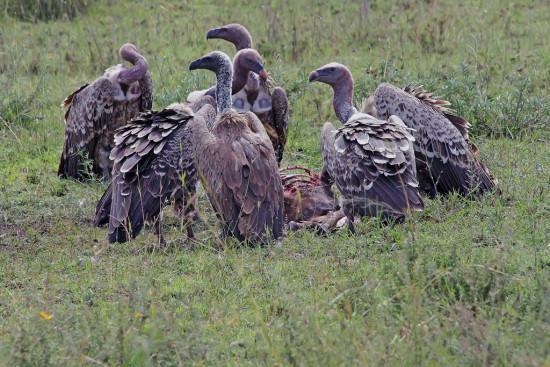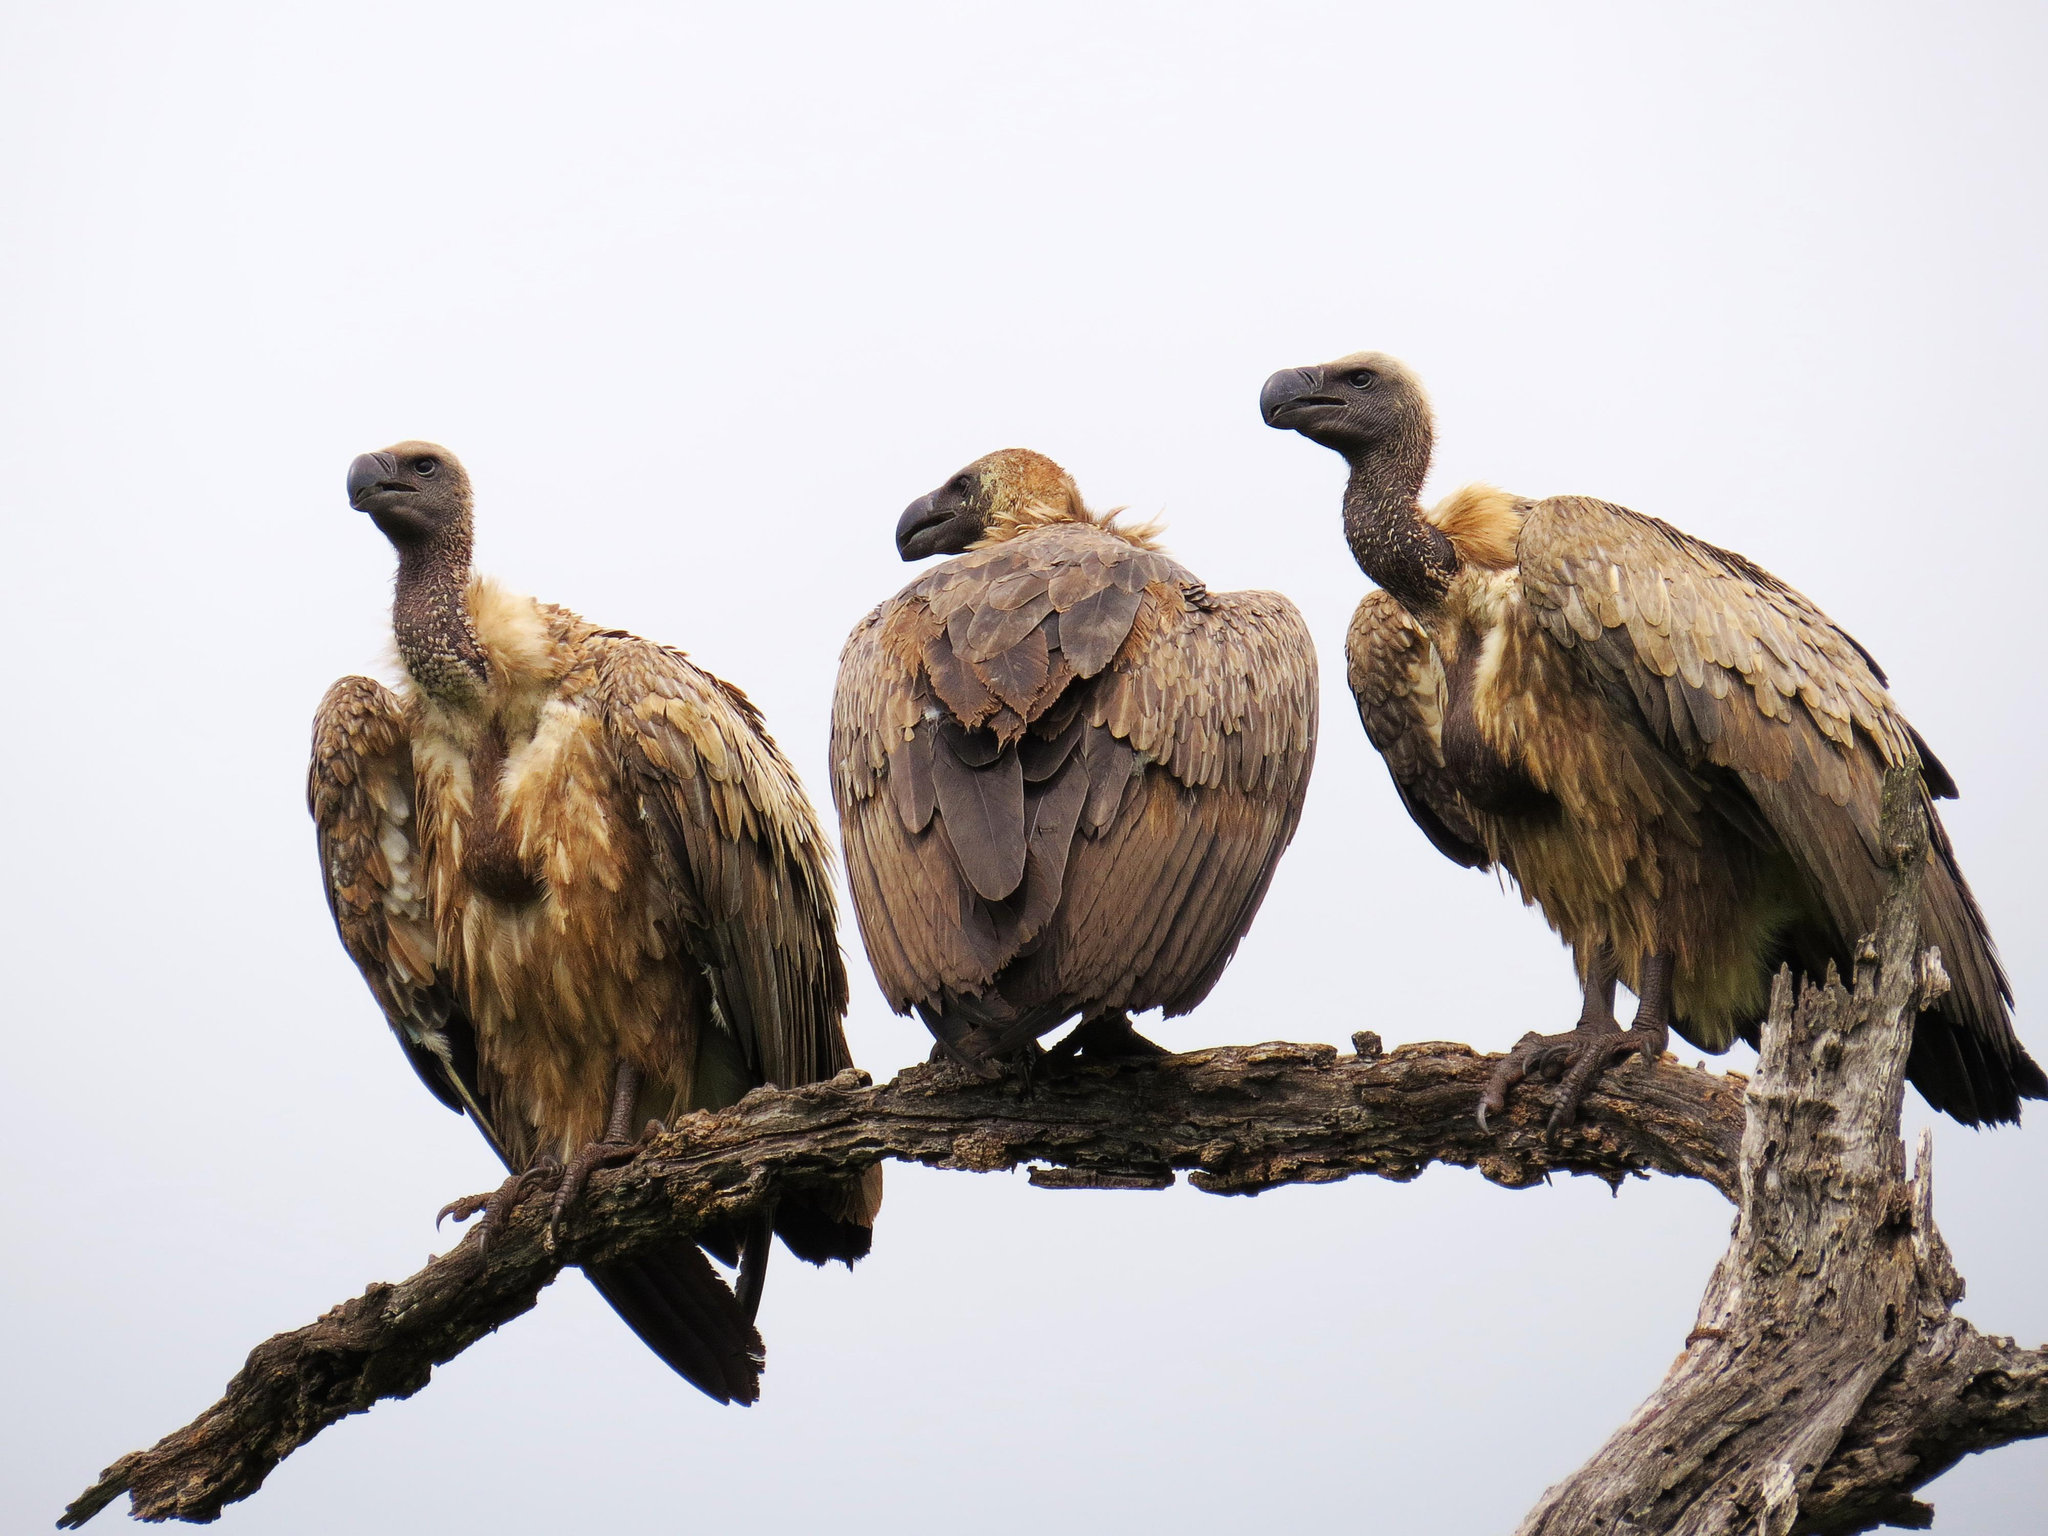The first image is the image on the left, the second image is the image on the right. For the images shown, is this caption "Three or more vultures perched on a branch are visible." true? Answer yes or no. Yes. The first image is the image on the left, the second image is the image on the right. Evaluate the accuracy of this statement regarding the images: "There is a group of at least 5 vultures in the right image.". Is it true? Answer yes or no. No. 